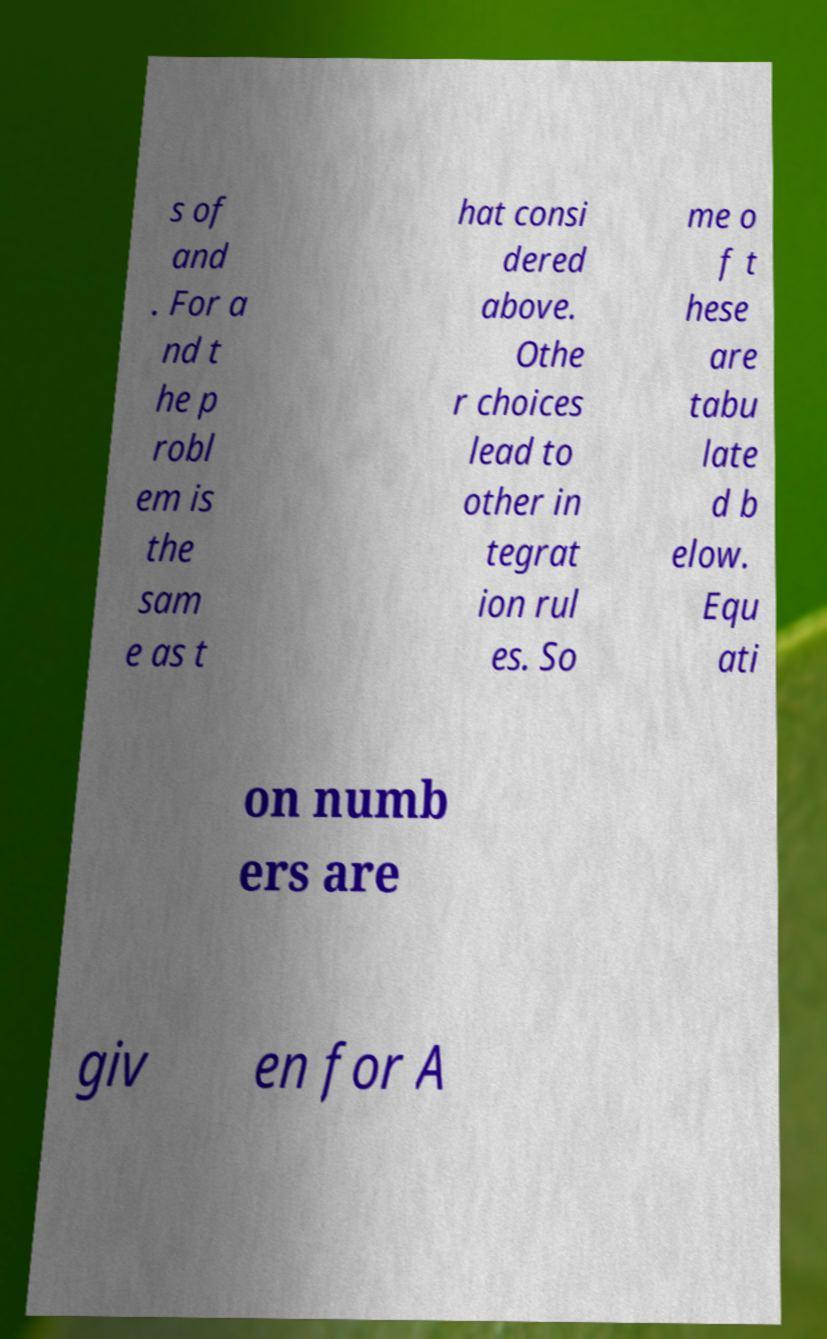Please read and relay the text visible in this image. What does it say? s of and . For a nd t he p robl em is the sam e as t hat consi dered above. Othe r choices lead to other in tegrat ion rul es. So me o f t hese are tabu late d b elow. Equ ati on numb ers are giv en for A 